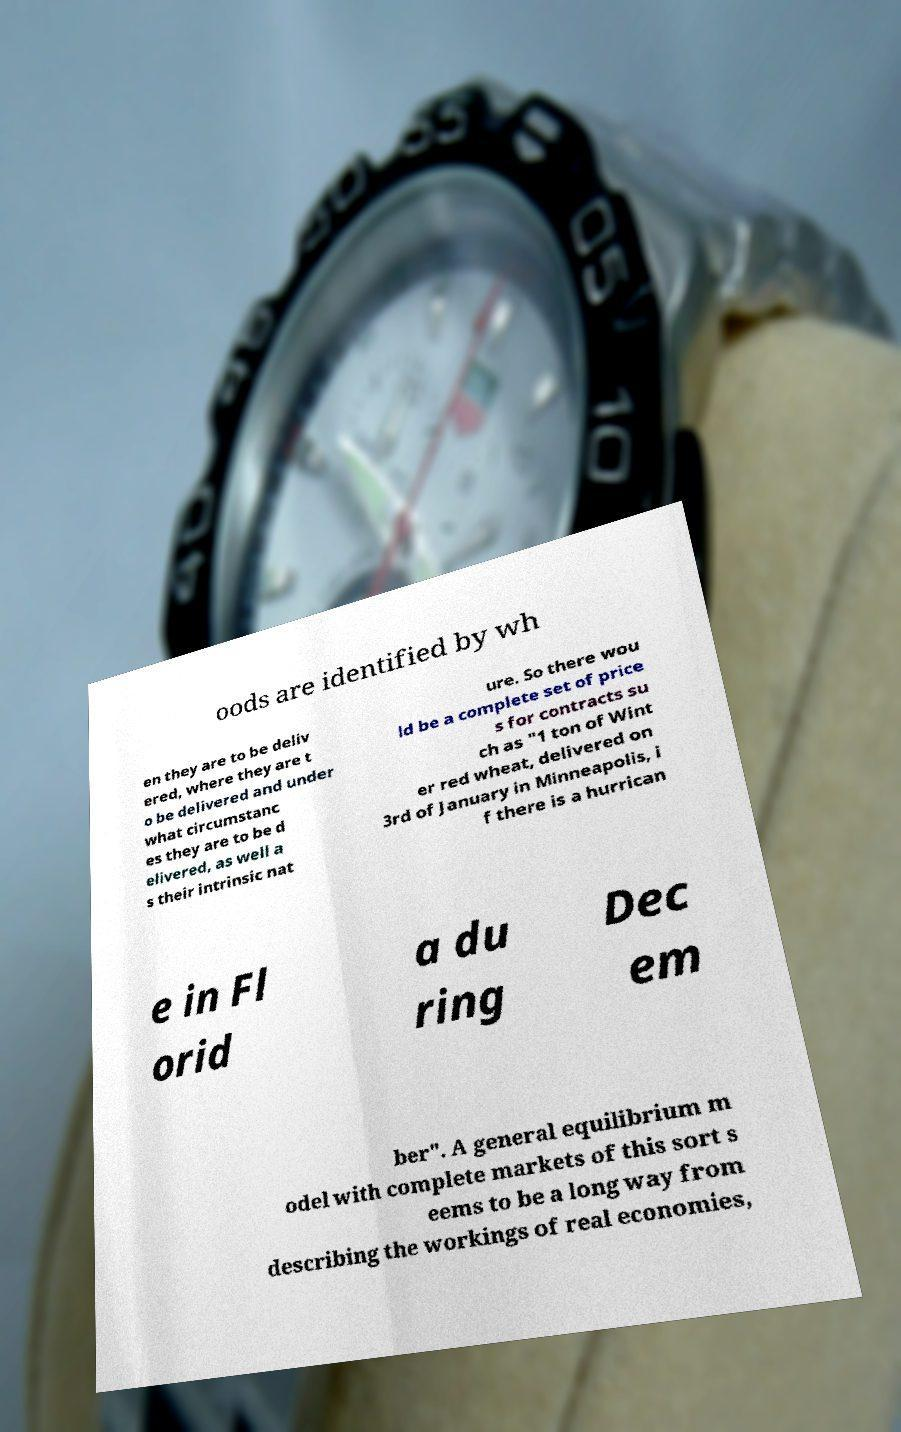For documentation purposes, I need the text within this image transcribed. Could you provide that? oods are identified by wh en they are to be deliv ered, where they are t o be delivered and under what circumstanc es they are to be d elivered, as well a s their intrinsic nat ure. So there wou ld be a complete set of price s for contracts su ch as "1 ton of Wint er red wheat, delivered on 3rd of January in Minneapolis, i f there is a hurrican e in Fl orid a du ring Dec em ber". A general equilibrium m odel with complete markets of this sort s eems to be a long way from describing the workings of real economies, 